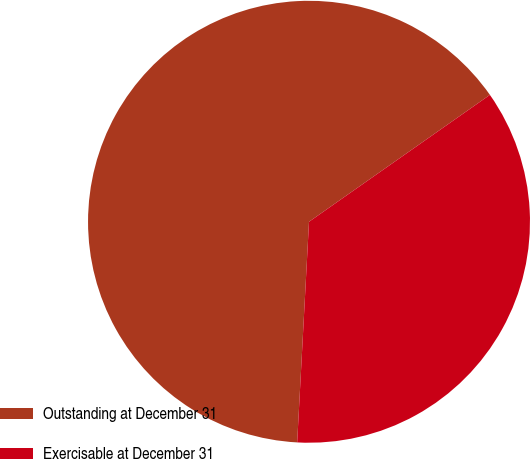Convert chart to OTSL. <chart><loc_0><loc_0><loc_500><loc_500><pie_chart><fcel>Outstanding at December 31<fcel>Exercisable at December 31<nl><fcel>64.41%<fcel>35.59%<nl></chart> 